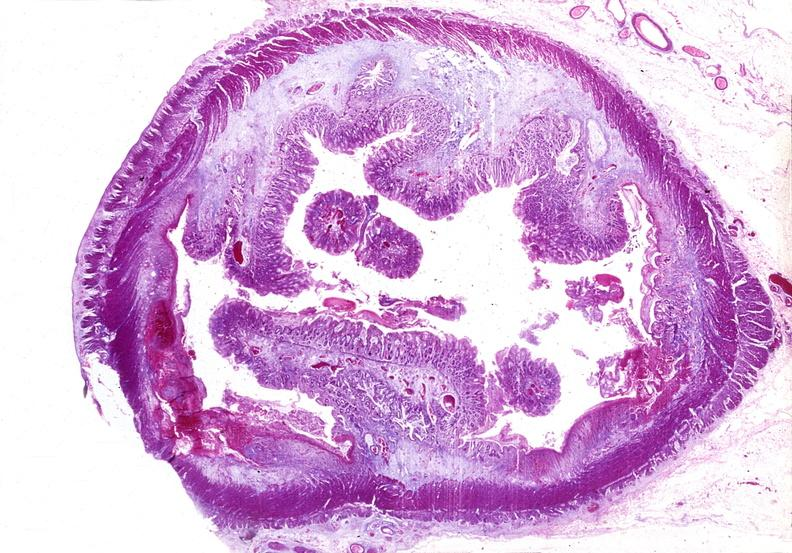does this image show colon, chronic ulcerative colitis, pseudopolyps?
Answer the question using a single word or phrase. Yes 